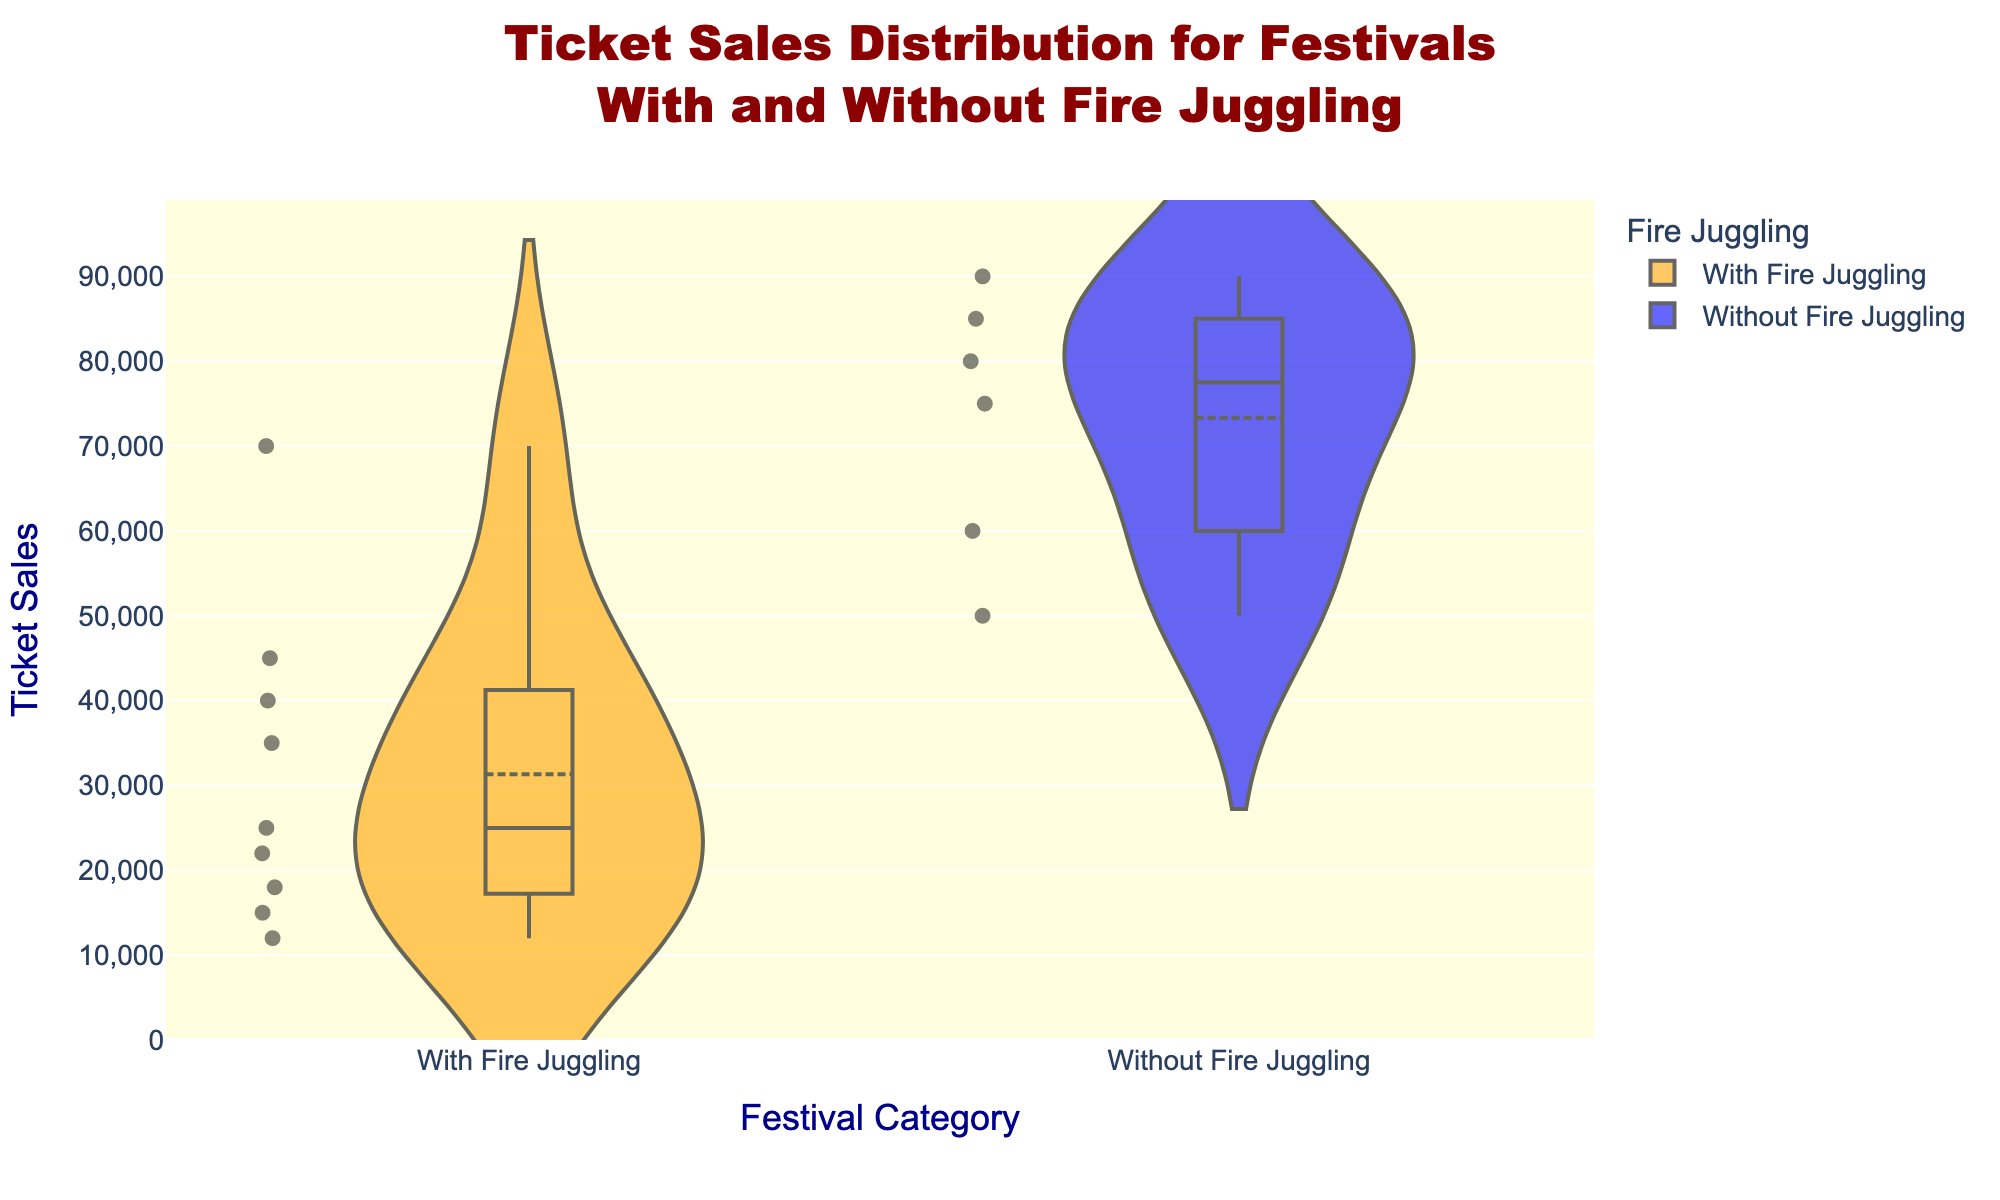What is the title of the violin chart? The title of the violin chart is prominently displayed at the top and gives an overview of what the chart represents. In this figure, the title is “Ticket Sales Distribution for Festivals With and Without Fire Juggling.”
Answer: Ticket Sales Distribution for Festivals With and Without Fire Juggling What are the categories on the x-axis? The x-axis shows two categories which represent data for festivals "With Fire Juggling" and "Without Fire Juggling." These categories are used to distribute the data accordingly.
Answer: With Fire Juggling and Without Fire Juggling What is the range of ticket sales on the y-axis? The y-axis displays the ticket sales in a numeric format. The range of the y-axis goes from 0 to a little above the maximum recorded ticket sales in the dataset. Given the highest value is 90,000, the y-axis should cap around 95,000.
Answer: 0 to 95,000 Which category has the higher median ticket sales? The median is represented as a line within each violin plot. By comparing the median lines in both categories, it is evident that the median ticket sales for the "Without Fire Juggling" category are higher than those for the "With Fire Juggling" category.
Answer: Without Fire Juggling How many festivals feature fire juggling? Each point on the violin chart represents a festival. By counting the number of data points within the "With Fire Juggling" category, we can determine the number of festivals. According to the data, there are 9 festivals that feature fire juggling.
Answer: 9 What is the highest ticket sales value for a festival with fire juggling? Within the "With Fire Juggling" violin plot, the highest point represents the maximum ticket sales for a festival that features fire juggling. Based on the given data, the highest ticket sales for this category are from Burning Man, with 45,000 tickets.
Answer: 45,000 What is the difference between the maximum ticket sales for festivals with and without fire juggling? By identifying the highest values for both categories: Without Fire Juggling (90,000) and With Fire Juggling (45,000), and computing the difference, we get 90,000 - 45,000.
Answer: 45,000 What is the interquartile range (IQR) for ticket sales in the category without fire juggling? The IQR is calculated as the difference between the 75th percentile (the upper line of the box) and the 25th percentile (the lower line of the box). From the violin plot of festivals without fire juggling, visually estimate these percentiles and calculate the IQR. The lower quartile is approximately 50,000 and the upper quartile is around 85,000. So, IQR = 85,000 - 50,000.
Answer: 35,000 Which category has more outliers in terms of ticket sales? Outliers are typically represented as distinct points outside the whiskers of the box plot overlay on the violin chart. By counting these points for each category, the category "With Fire Juggling" has more outliers as it has several points such as the Montreux Jazz Festival (12,000) and Just for Laughs (15,000) which are distant from the other data points.
Answer: With Fire Juggling 